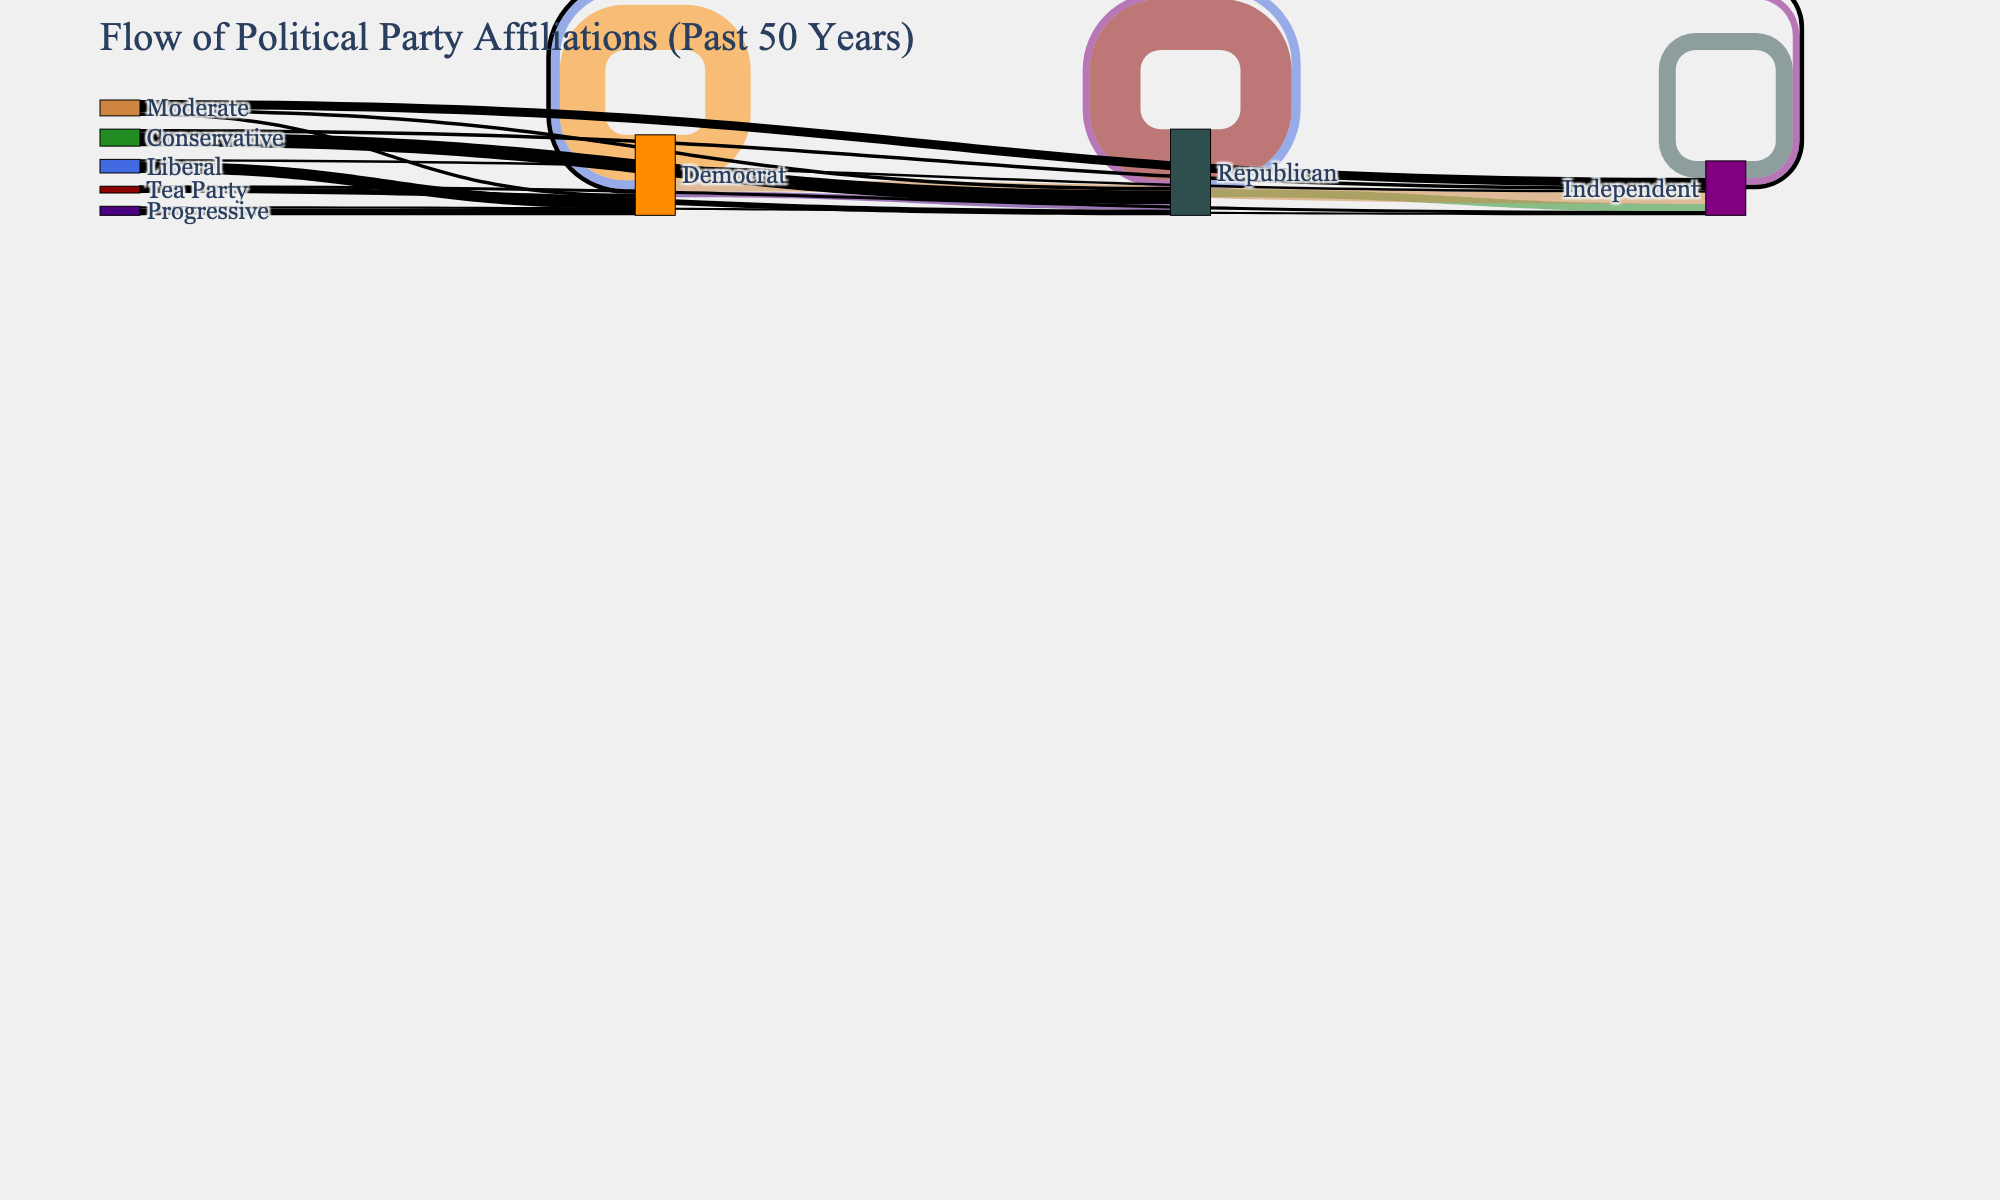How many people originally identified as Republicans in the dataset? According to the figure, the transitions originating from "Republican" total to values (45 + 8 + 7), indicating the total amount of Republicans
Answer: 60 How many people switched their political affiliation from Democrat to Independent? The figure shows an arrow from "Democrat" to "Independent" with value 10, indicating the transitions.
Answer: 10 Which group has the highest number of people remaining in the same affiliation? By examining the figure, the arrows showing people staying within the same group have values of: Republican (45), Democrat (40), and Independent (15). Among these, Republican is the highest.
Answer: Republican What is the total number of people that shifted their affiliation to become Republicans, across all initial affiliations? The figure shows arrows towards "Republican" from different origins: Democrat (5), Independent (6), Conservative (12), and Tea Party (5). Adding these values gives us (5 + 6 + 12 + 5).
Answer: 28 How many people in total identified as Independents according to the figure? Considering both origins and transitions, the figure displays transitions involving Independents as (7 + 10 + 15 + 3 + 2 + 1 + 2 + 8 + 6 + 4 + 3). Adding these values gives the total number.
Answer: 61 Compare the number of Conservatives switching to Independents to the number of Progressives doing the same. Which is higher? The figure shows an arrow for "Conservative" to "Independent" with a value of 3 and "Progressive" to "Independent" with a value of 2. Comparing these values, Conservatives switching to Independents is higher.
Answer: Conservatives Which political affiliation had the lowest retention rate, and what value does it have? To find the retention rate, we need to look at the self-loop arrows. The figure shows the transitions of Republican (45), Democrat (40), and Independent (15). Independent has the lowest value.
Answer: Independent with 15 What is the total number of people who identified as Democrats, including those who changed their affiliation? By looking at the origins and transitions involving Democrats: (40 + 5 + 10 + 4 + 3 + 6), calculating the total number gives (68).
Answer: 68 How many different political affiliations did the Moderate group transition into? From the figure, we see the arrows originating from "Moderate" lead to Independent, Republican, and Democrat. This shows three different destinations.
Answer: 3 